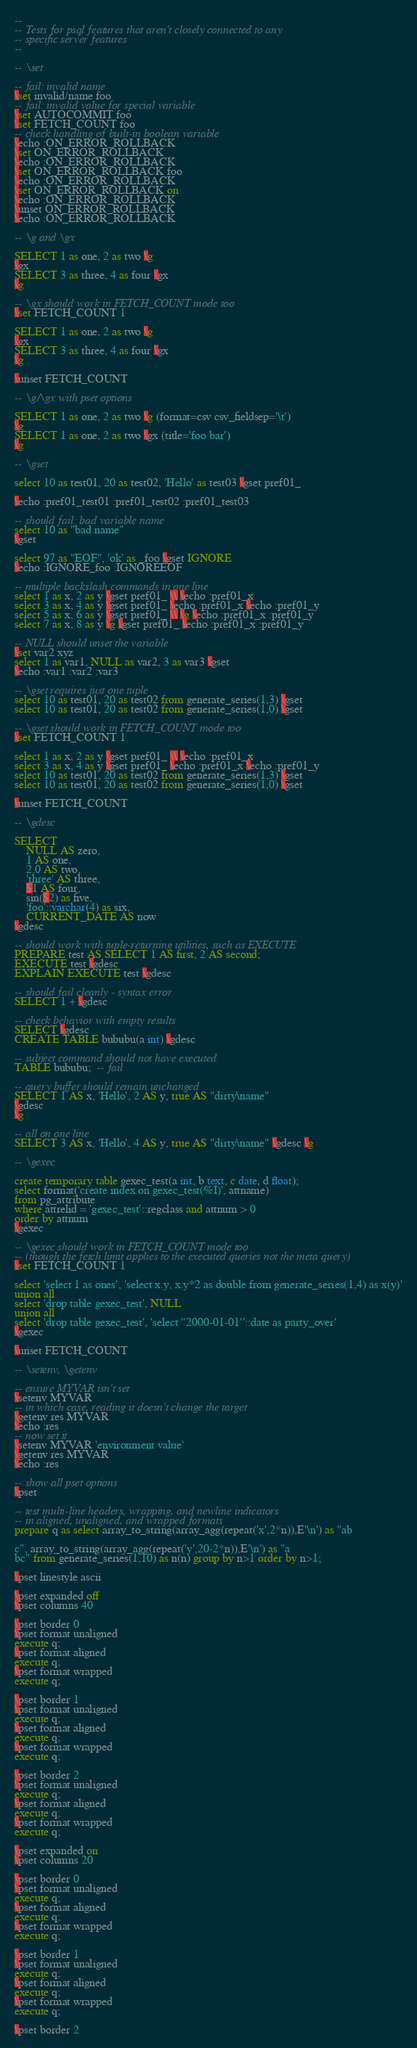Convert code to text. <code><loc_0><loc_0><loc_500><loc_500><_SQL_>--
-- Tests for psql features that aren't closely connected to any
-- specific server features
--

-- \set

-- fail: invalid name
\set invalid/name foo
-- fail: invalid value for special variable
\set AUTOCOMMIT foo
\set FETCH_COUNT foo
-- check handling of built-in boolean variable
\echo :ON_ERROR_ROLLBACK
\set ON_ERROR_ROLLBACK
\echo :ON_ERROR_ROLLBACK
\set ON_ERROR_ROLLBACK foo
\echo :ON_ERROR_ROLLBACK
\set ON_ERROR_ROLLBACK on
\echo :ON_ERROR_ROLLBACK
\unset ON_ERROR_ROLLBACK
\echo :ON_ERROR_ROLLBACK

-- \g and \gx

SELECT 1 as one, 2 as two \g
\gx
SELECT 3 as three, 4 as four \gx
\g

-- \gx should work in FETCH_COUNT mode too
\set FETCH_COUNT 1

SELECT 1 as one, 2 as two \g
\gx
SELECT 3 as three, 4 as four \gx
\g

\unset FETCH_COUNT

-- \g/\gx with pset options

SELECT 1 as one, 2 as two \g (format=csv csv_fieldsep='\t')
\g
SELECT 1 as one, 2 as two \gx (title='foo bar')
\g

-- \gset

select 10 as test01, 20 as test02, 'Hello' as test03 \gset pref01_

\echo :pref01_test01 :pref01_test02 :pref01_test03

-- should fail: bad variable name
select 10 as "bad name"
\gset

select 97 as "EOF", 'ok' as _foo \gset IGNORE
\echo :IGNORE_foo :IGNOREEOF

-- multiple backslash commands in one line
select 1 as x, 2 as y \gset pref01_ \\ \echo :pref01_x
select 3 as x, 4 as y \gset pref01_ \echo :pref01_x \echo :pref01_y
select 5 as x, 6 as y \gset pref01_ \\ \g \echo :pref01_x :pref01_y
select 7 as x, 8 as y \g \gset pref01_ \echo :pref01_x :pref01_y

-- NULL should unset the variable
\set var2 xyz
select 1 as var1, NULL as var2, 3 as var3 \gset
\echo :var1 :var2 :var3

-- \gset requires just one tuple
select 10 as test01, 20 as test02 from generate_series(1,3) \gset
select 10 as test01, 20 as test02 from generate_series(1,0) \gset

-- \gset should work in FETCH_COUNT mode too
\set FETCH_COUNT 1

select 1 as x, 2 as y \gset pref01_ \\ \echo :pref01_x
select 3 as x, 4 as y \gset pref01_ \echo :pref01_x \echo :pref01_y
select 10 as test01, 20 as test02 from generate_series(1,3) \gset
select 10 as test01, 20 as test02 from generate_series(1,0) \gset

\unset FETCH_COUNT

-- \gdesc

SELECT
    NULL AS zero,
    1 AS one,
    2.0 AS two,
    'three' AS three,
    $1 AS four,
    sin($2) as five,
    'foo'::varchar(4) as six,
    CURRENT_DATE AS now
\gdesc

-- should work with tuple-returning utilities, such as EXECUTE
PREPARE test AS SELECT 1 AS first, 2 AS second;
EXECUTE test \gdesc
EXPLAIN EXECUTE test \gdesc

-- should fail cleanly - syntax error
SELECT 1 + \gdesc

-- check behavior with empty results
SELECT \gdesc
CREATE TABLE bububu(a int) \gdesc

-- subject command should not have executed
TABLE bububu;  -- fail

-- query buffer should remain unchanged
SELECT 1 AS x, 'Hello', 2 AS y, true AS "dirty\name"
\gdesc
\g

-- all on one line
SELECT 3 AS x, 'Hello', 4 AS y, true AS "dirty\name" \gdesc \g

-- \gexec

create temporary table gexec_test(a int, b text, c date, d float);
select format('create index on gexec_test(%I)', attname)
from pg_attribute
where attrelid = 'gexec_test'::regclass and attnum > 0
order by attnum
\gexec

-- \gexec should work in FETCH_COUNT mode too
-- (though the fetch limit applies to the executed queries not the meta query)
\set FETCH_COUNT 1

select 'select 1 as ones', 'select x.y, x.y*2 as double from generate_series(1,4) as x(y)'
union all
select 'drop table gexec_test', NULL
union all
select 'drop table gexec_test', 'select ''2000-01-01''::date as party_over'
\gexec

\unset FETCH_COUNT

-- \setenv, \getenv

-- ensure MYVAR isn't set
\setenv MYVAR
-- in which case, reading it doesn't change the target
\getenv res MYVAR
\echo :res
-- now set it
\setenv MYVAR 'environment value'
\getenv res MYVAR
\echo :res

-- show all pset options
\pset

-- test multi-line headers, wrapping, and newline indicators
-- in aligned, unaligned, and wrapped formats
prepare q as select array_to_string(array_agg(repeat('x',2*n)),E'\n') as "ab

c", array_to_string(array_agg(repeat('y',20-2*n)),E'\n') as "a
bc" from generate_series(1,10) as n(n) group by n>1 order by n>1;

\pset linestyle ascii

\pset expanded off
\pset columns 40

\pset border 0
\pset format unaligned
execute q;
\pset format aligned
execute q;
\pset format wrapped
execute q;

\pset border 1
\pset format unaligned
execute q;
\pset format aligned
execute q;
\pset format wrapped
execute q;

\pset border 2
\pset format unaligned
execute q;
\pset format aligned
execute q;
\pset format wrapped
execute q;

\pset expanded on
\pset columns 20

\pset border 0
\pset format unaligned
execute q;
\pset format aligned
execute q;
\pset format wrapped
execute q;

\pset border 1
\pset format unaligned
execute q;
\pset format aligned
execute q;
\pset format wrapped
execute q;

\pset border 2</code> 